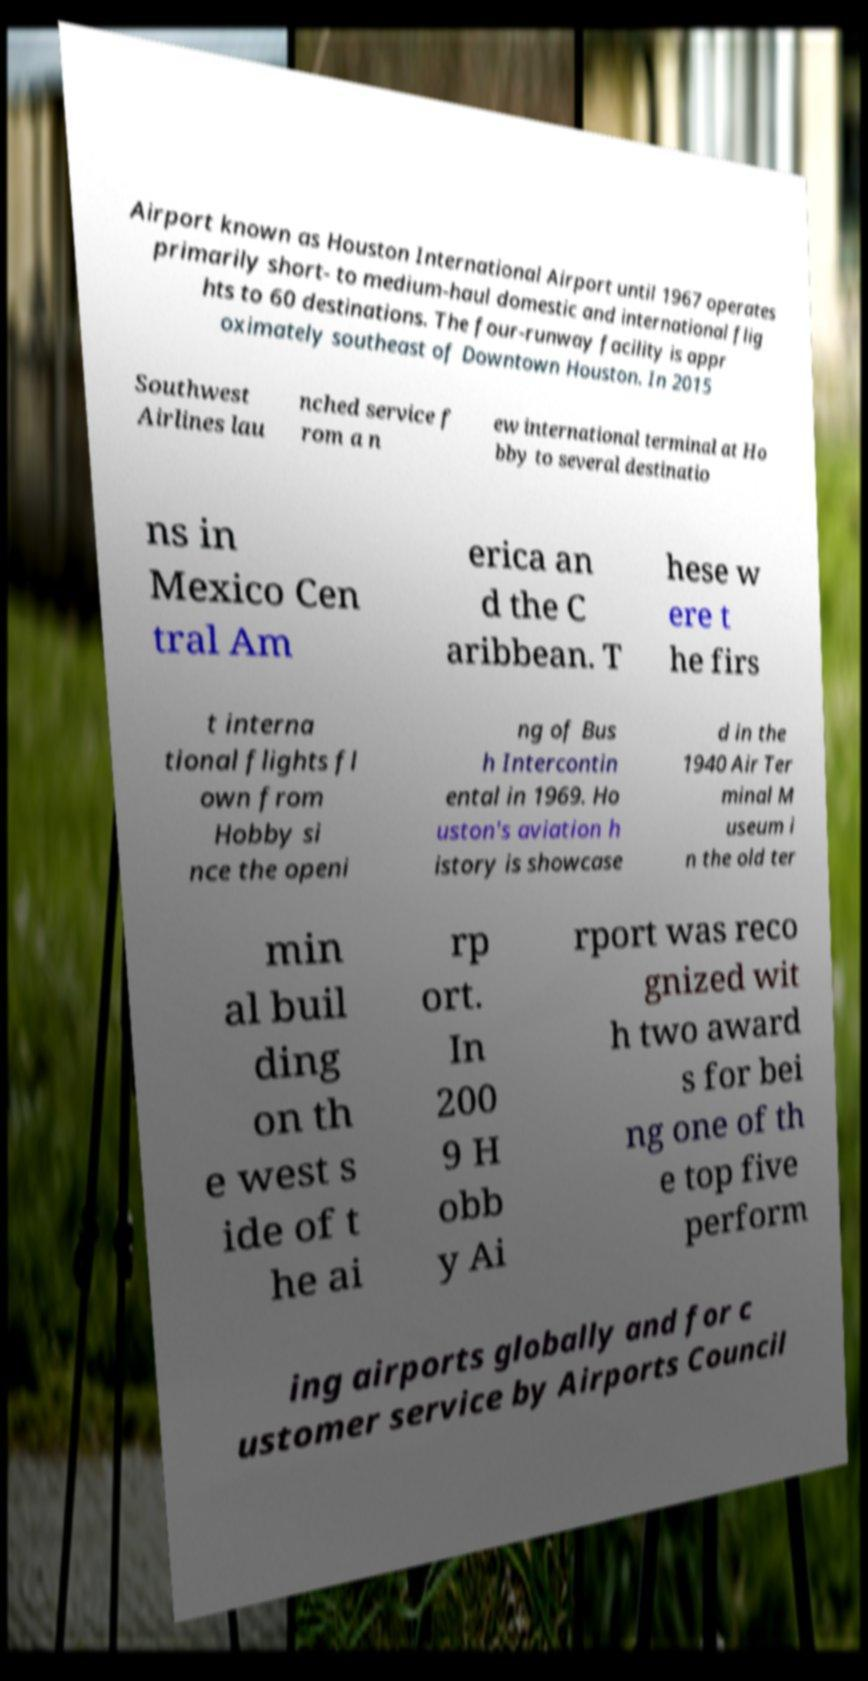I need the written content from this picture converted into text. Can you do that? Airport known as Houston International Airport until 1967 operates primarily short- to medium-haul domestic and international flig hts to 60 destinations. The four-runway facility is appr oximately southeast of Downtown Houston. In 2015 Southwest Airlines lau nched service f rom a n ew international terminal at Ho bby to several destinatio ns in Mexico Cen tral Am erica an d the C aribbean. T hese w ere t he firs t interna tional flights fl own from Hobby si nce the openi ng of Bus h Intercontin ental in 1969. Ho uston's aviation h istory is showcase d in the 1940 Air Ter minal M useum i n the old ter min al buil ding on th e west s ide of t he ai rp ort. In 200 9 H obb y Ai rport was reco gnized wit h two award s for bei ng one of th e top five perform ing airports globally and for c ustomer service by Airports Council 